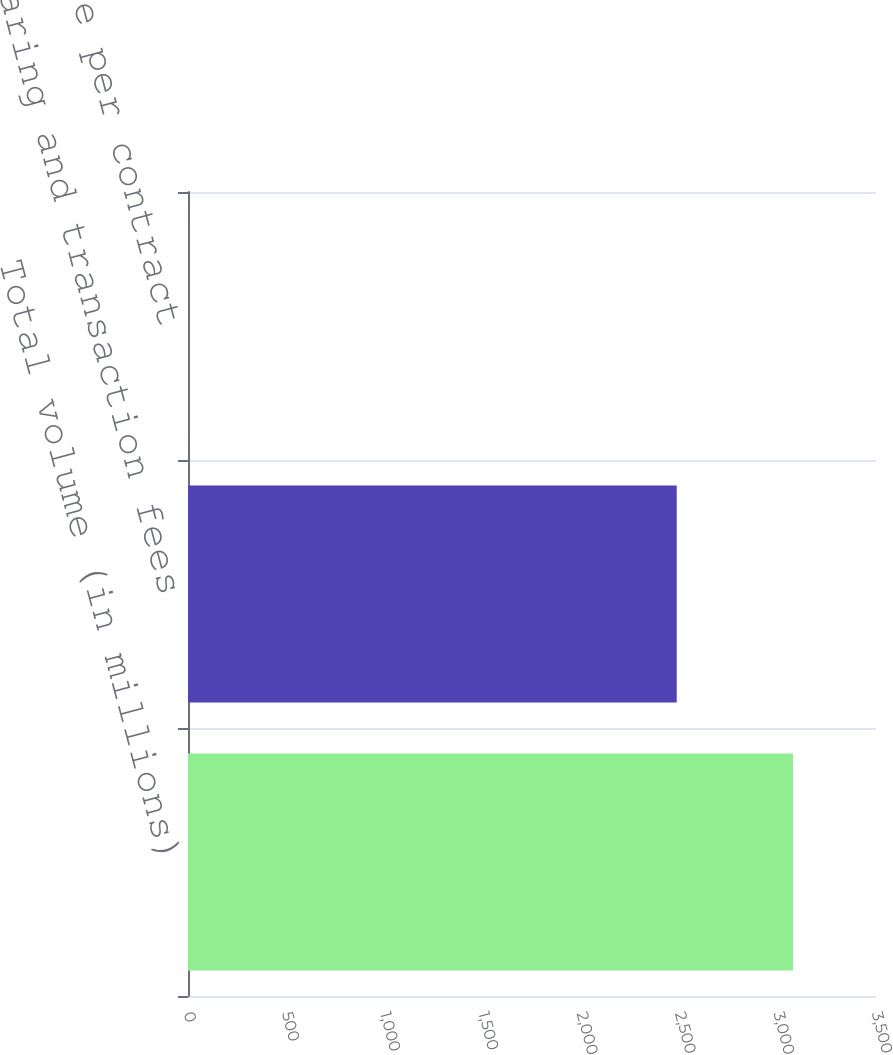Convert chart to OTSL. <chart><loc_0><loc_0><loc_500><loc_500><bar_chart><fcel>Total volume (in millions)<fcel>Clearing and transaction fees<fcel>Average rate per contract<nl><fcel>3078.1<fcel>2486.3<fcel>0.81<nl></chart> 